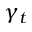<formula> <loc_0><loc_0><loc_500><loc_500>\gamma _ { t }</formula> 